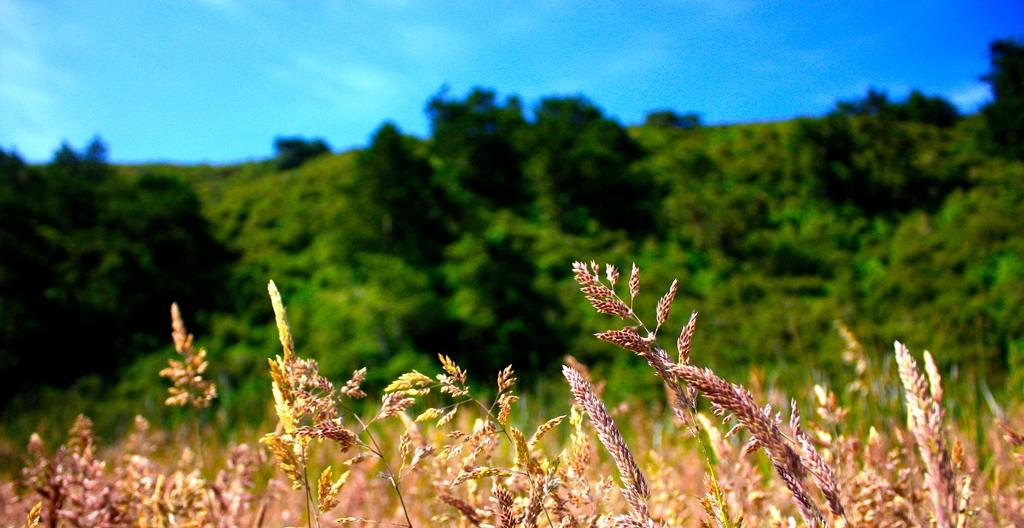What is present in the image? There are plants in the image. What can be seen in the background of the plants? The background of the plants has a lot of greenery. What type of pancake can be seen in the image? There is no pancake present in the image; it features plants with a green background. 